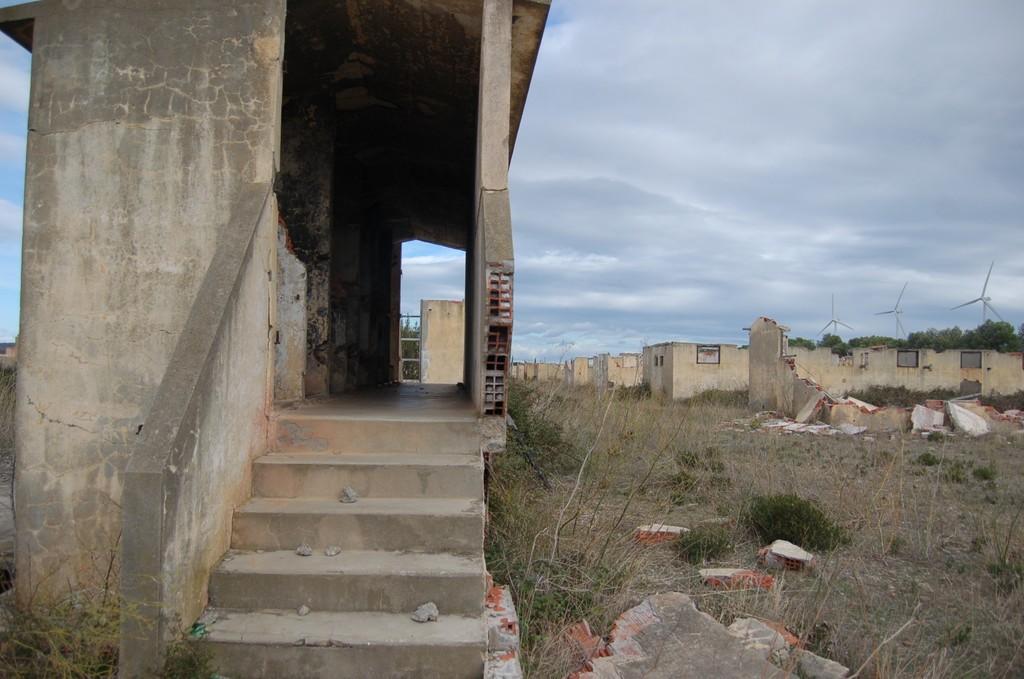How would you summarize this image in a sentence or two? This picture is clicked outside the city. At the bottom of the picture, we see an old building and a staircase. In the right bottom of the picture, we see plants and grass. There are many buildings and trees in the background. We even see windmills. At the top of the picture, we see the sky. 